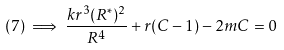<formula> <loc_0><loc_0><loc_500><loc_500>( 7 ) \implies \frac { k r ^ { 3 } ( R ^ { \ast } ) ^ { 2 } } { R ^ { 4 } } + r ( C - 1 ) - 2 m C = 0</formula> 